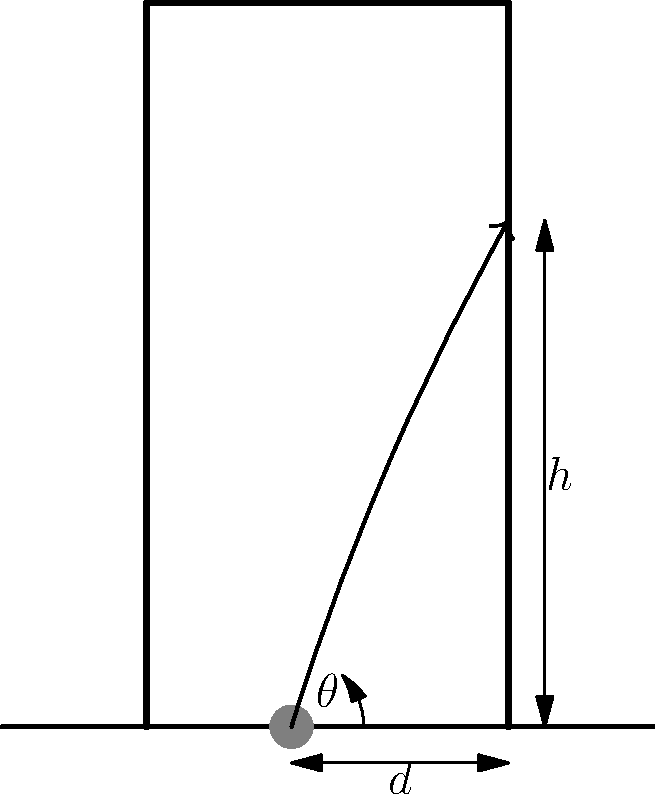A rugby player is attempting a conversion kick from a distance $d$ meters away from the goal post, which has a height of $h$ meters. The player kicks the ball at an angle $\theta$ from the ground. Assuming the ball follows a parabolic path and neglecting air resistance, what is the optimal angle $\theta$ that maximizes the chance of a successful kick? Let's approach this step-by-step:

1) The trajectory of the ball can be described by the equation of projectile motion:

   $y = x \tan\theta - \frac{gx^2}{2v_0^2\cos^2\theta}$

   where $g$ is the acceleration due to gravity, and $v_0$ is the initial velocity.

2) For the kick to be successful, the ball must clear the crossbar. This means that when $x = d$, $y$ must be greater than or equal to $h$:

   $h \leq d \tan\theta - \frac{gd^2}{2v_0^2\cos^2\theta}$

3) The optimal angle will be the one that just clears the crossbar, so we can replace the inequality with an equality:

   $h = d \tan\theta - \frac{gd^2}{2v_0^2\cos^2\theta}$

4) To maximize the chances of success, we want to minimize the required initial velocity $v_0$. We can rearrange the equation to solve for $v_0^2$:

   $v_0^2 = \frac{gd^2}{2\cos^2\theta(d\tan\theta - h)}$

5) To find the minimum value of $v_0^2$, we differentiate with respect to $\theta$ and set it to zero:

   $\frac{d(v_0^2)}{d\theta} = 0$

6) After differentiation and simplification, we get:

   $\tan\theta = \frac{3h}{2d}$

7) Taking the inverse tangent of both sides:

   $\theta = \arctan(\frac{3h}{2d})$

This is the optimal angle for the kick.
Answer: $\theta = \arctan(\frac{3h}{2d})$ 